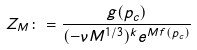Convert formula to latex. <formula><loc_0><loc_0><loc_500><loc_500>Z _ { M } \colon = \frac { g ( p _ { c } ) } { ( - \nu M ^ { 1 / 3 } ) ^ { k } e ^ { M f ( p _ { c } ) } }</formula> 